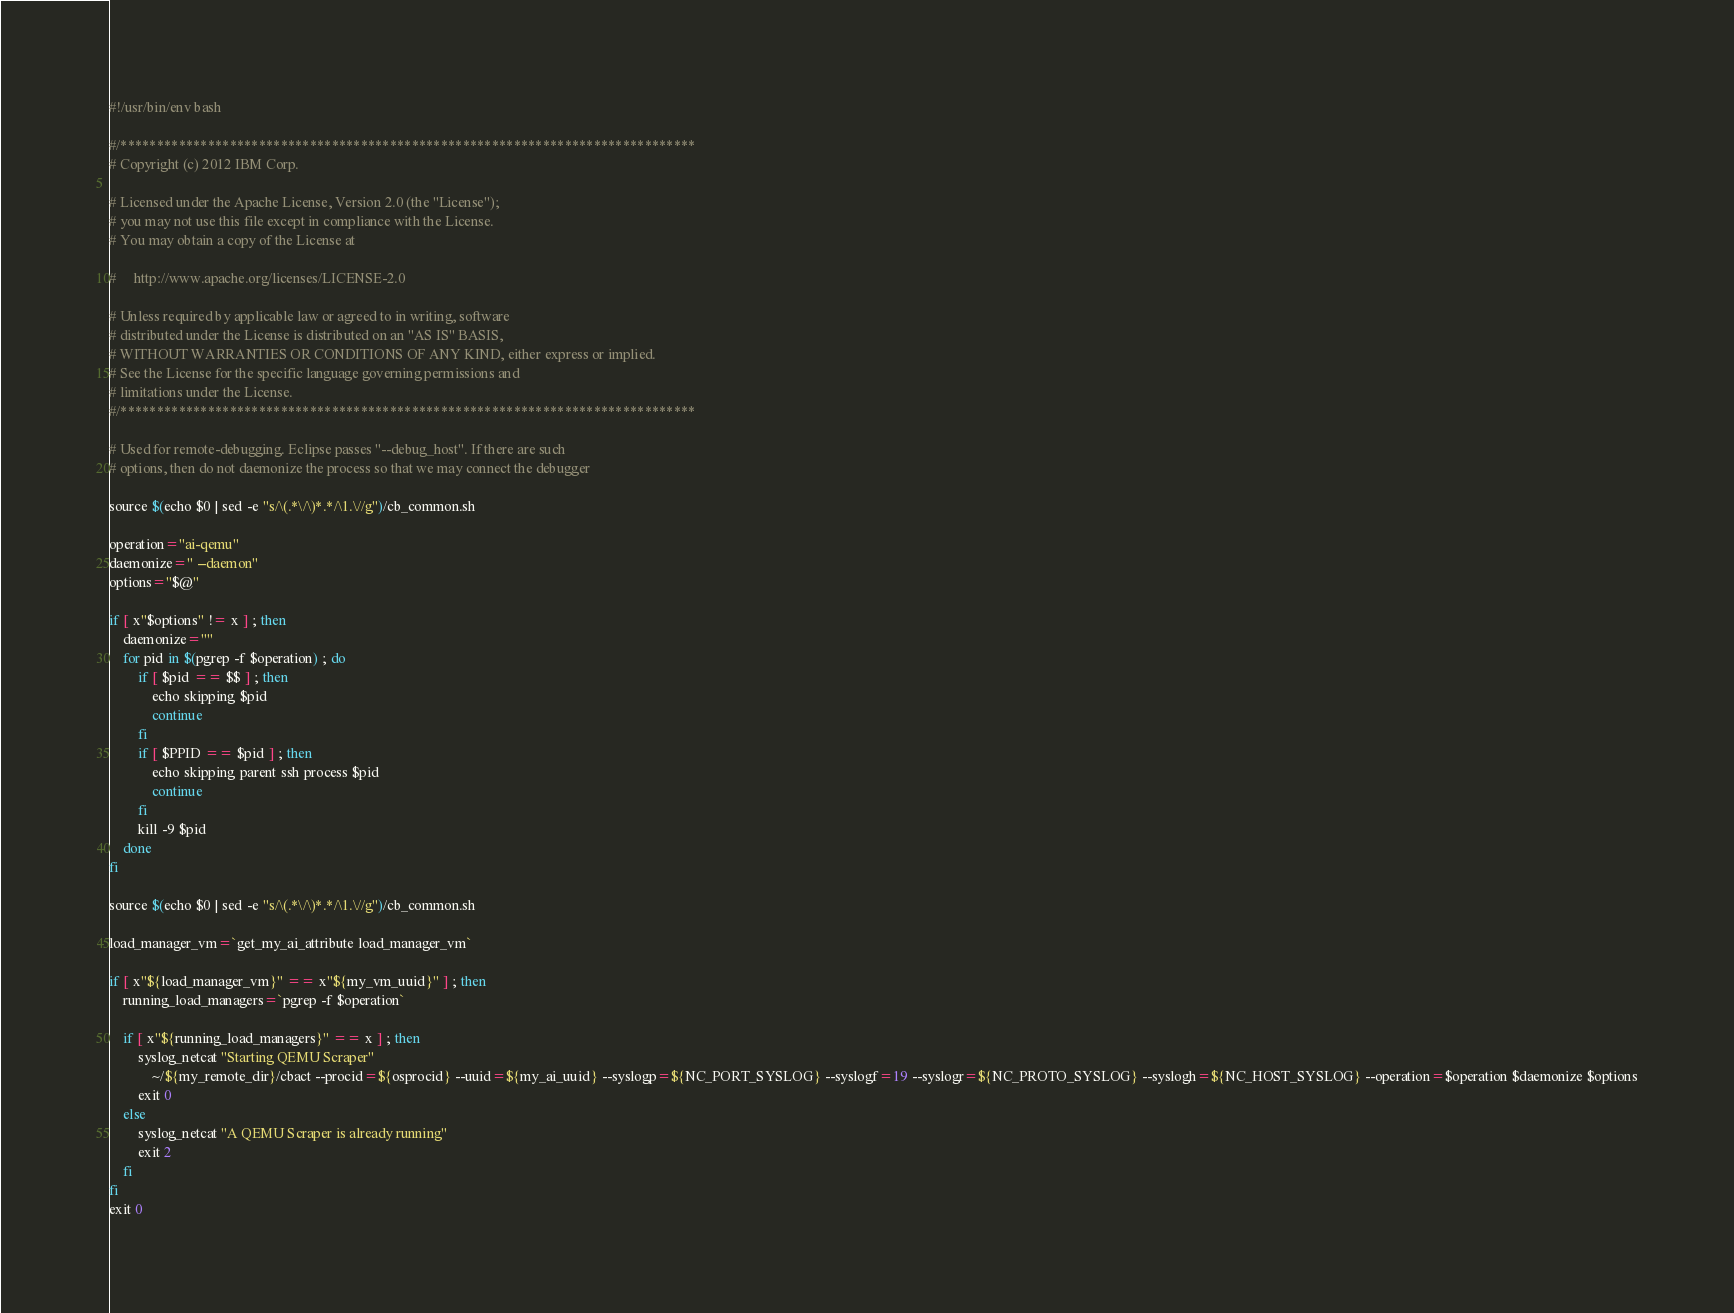<code> <loc_0><loc_0><loc_500><loc_500><_Bash_>#!/usr/bin/env bash

#/*******************************************************************************
# Copyright (c) 2012 IBM Corp.

# Licensed under the Apache License, Version 2.0 (the "License");
# you may not use this file except in compliance with the License.
# You may obtain a copy of the License at

#     http://www.apache.org/licenses/LICENSE-2.0

# Unless required by applicable law or agreed to in writing, software
# distributed under the License is distributed on an "AS IS" BASIS,
# WITHOUT WARRANTIES OR CONDITIONS OF ANY KIND, either express or implied.
# See the License for the specific language governing permissions and
# limitations under the License.
#/*******************************************************************************

# Used for remote-debugging. Eclipse passes "--debug_host". If there are such
# options, then do not daemonize the process so that we may connect the debugger

source $(echo $0 | sed -e "s/\(.*\/\)*.*/\1.\//g")/cb_common.sh

operation="ai-qemu"
daemonize=" --daemon"
options="$@"

if [ x"$options" != x ] ; then
	daemonize=""
	for pid in $(pgrep -f $operation) ; do 
		if [ $pid == $$ ] ; then 
			echo skipping $pid
			continue
		fi
		if [ $PPID == $pid ] ; then 
			echo skipping parent ssh process $pid
			continue
		fi
		kill -9 $pid
	done
fi

source $(echo $0 | sed -e "s/\(.*\/\)*.*/\1.\//g")/cb_common.sh

load_manager_vm=`get_my_ai_attribute load_manager_vm`

if [ x"${load_manager_vm}" == x"${my_vm_uuid}" ] ; then
	running_load_managers=`pgrep -f $operation`
	
	if [ x"${running_load_managers}" == x ] ; then
	    syslog_netcat "Starting QEMU Scraper"
            ~/${my_remote_dir}/cbact --procid=${osprocid} --uuid=${my_ai_uuid} --syslogp=${NC_PORT_SYSLOG} --syslogf=19 --syslogr=${NC_PROTO_SYSLOG} --syslogh=${NC_HOST_SYSLOG} --operation=$operation $daemonize $options
	    exit 0
	else
	    syslog_netcat "A QEMU Scraper is already running"
	    exit 2
	fi
fi
exit 0
</code> 